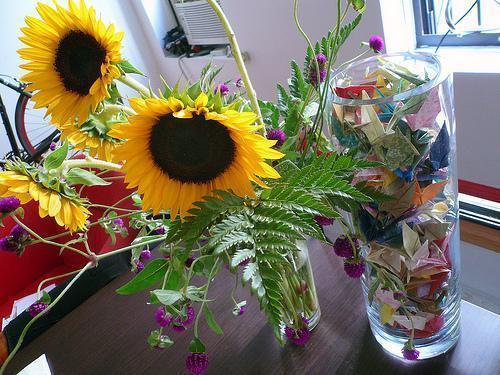How many sunflowers are there?
Give a very brief answer. 4. 